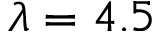Convert formula to latex. <formula><loc_0><loc_0><loc_500><loc_500>\lambda = 4 . 5</formula> 